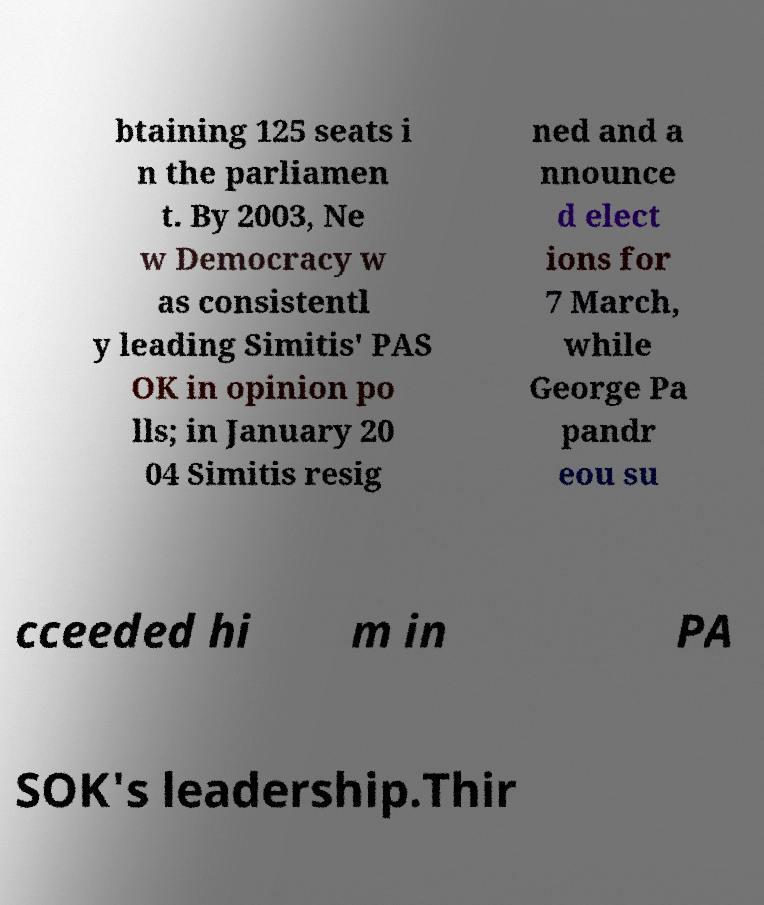Can you read and provide the text displayed in the image?This photo seems to have some interesting text. Can you extract and type it out for me? btaining 125 seats i n the parliamen t. By 2003, Ne w Democracy w as consistentl y leading Simitis' PAS OK in opinion po lls; in January 20 04 Simitis resig ned and a nnounce d elect ions for 7 March, while George Pa pandr eou su cceeded hi m in PA SOK's leadership.Thir 